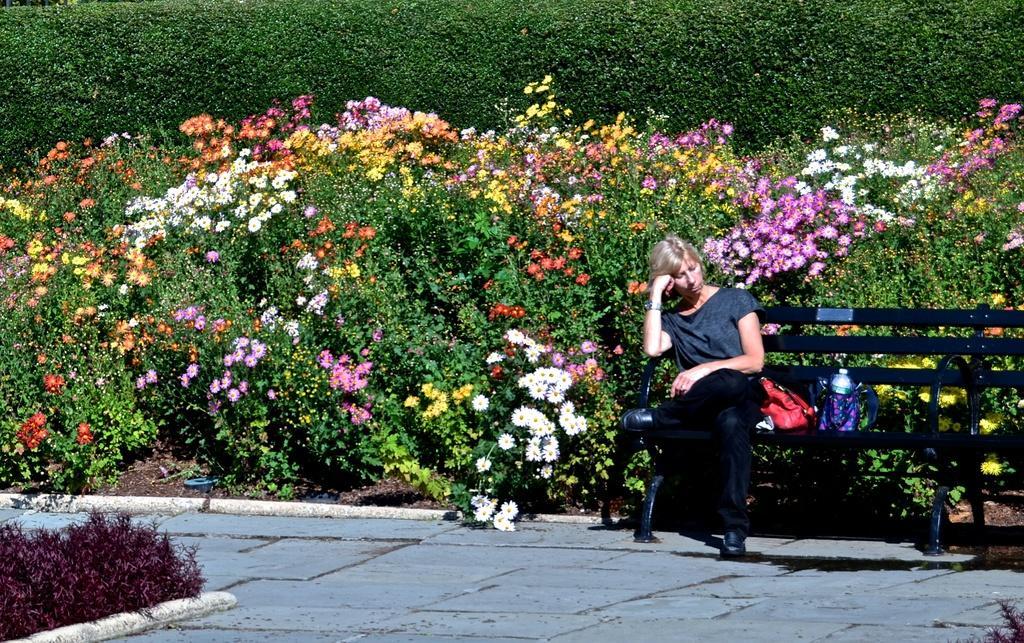Describe this image in one or two sentences. In this picture I see the path in front and on the right side of this picture I see a bench on which there is a woman sitting and I see the bags near to her and on the left side of this image, I see plants which are of dark pink in color. In the background I see number of plants and bushes and I see flowers which are of white, yellow, red, pink and orange in color. 